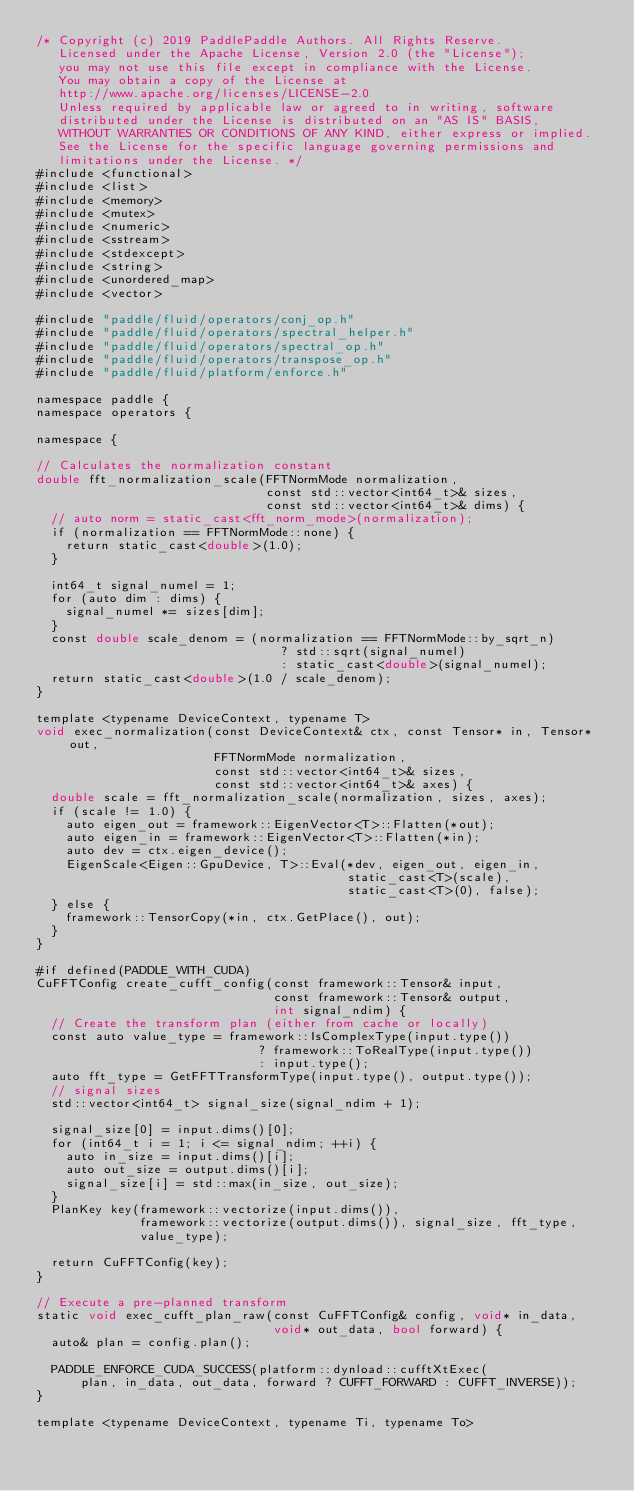<code> <loc_0><loc_0><loc_500><loc_500><_Cuda_>/* Copyright (c) 2019 PaddlePaddle Authors. All Rights Reserve.
   Licensed under the Apache License, Version 2.0 (the "License");
   you may not use this file except in compliance with the License.
   You may obtain a copy of the License at
   http://www.apache.org/licenses/LICENSE-2.0
   Unless required by applicable law or agreed to in writing, software
   distributed under the License is distributed on an "AS IS" BASIS,
   WITHOUT WARRANTIES OR CONDITIONS OF ANY KIND, either express or implied.
   See the License for the specific language governing permissions and
   limitations under the License. */
#include <functional>
#include <list>
#include <memory>
#include <mutex>
#include <numeric>
#include <sstream>
#include <stdexcept>
#include <string>
#include <unordered_map>
#include <vector>

#include "paddle/fluid/operators/conj_op.h"
#include "paddle/fluid/operators/spectral_helper.h"
#include "paddle/fluid/operators/spectral_op.h"
#include "paddle/fluid/operators/transpose_op.h"
#include "paddle/fluid/platform/enforce.h"

namespace paddle {
namespace operators {

namespace {

// Calculates the normalization constant
double fft_normalization_scale(FFTNormMode normalization,
                               const std::vector<int64_t>& sizes,
                               const std::vector<int64_t>& dims) {
  // auto norm = static_cast<fft_norm_mode>(normalization);
  if (normalization == FFTNormMode::none) {
    return static_cast<double>(1.0);
  }

  int64_t signal_numel = 1;
  for (auto dim : dims) {
    signal_numel *= sizes[dim];
  }
  const double scale_denom = (normalization == FFTNormMode::by_sqrt_n)
                                 ? std::sqrt(signal_numel)
                                 : static_cast<double>(signal_numel);
  return static_cast<double>(1.0 / scale_denom);
}

template <typename DeviceContext, typename T>
void exec_normalization(const DeviceContext& ctx, const Tensor* in, Tensor* out,
                        FFTNormMode normalization,
                        const std::vector<int64_t>& sizes,
                        const std::vector<int64_t>& axes) {
  double scale = fft_normalization_scale(normalization, sizes, axes);
  if (scale != 1.0) {
    auto eigen_out = framework::EigenVector<T>::Flatten(*out);
    auto eigen_in = framework::EigenVector<T>::Flatten(*in);
    auto dev = ctx.eigen_device();
    EigenScale<Eigen::GpuDevice, T>::Eval(*dev, eigen_out, eigen_in,
                                          static_cast<T>(scale),
                                          static_cast<T>(0), false);
  } else {
    framework::TensorCopy(*in, ctx.GetPlace(), out);
  }
}

#if defined(PADDLE_WITH_CUDA)
CuFFTConfig create_cufft_config(const framework::Tensor& input,
                                const framework::Tensor& output,
                                int signal_ndim) {
  // Create the transform plan (either from cache or locally)
  const auto value_type = framework::IsComplexType(input.type())
                              ? framework::ToRealType(input.type())
                              : input.type();
  auto fft_type = GetFFTTransformType(input.type(), output.type());
  // signal sizes
  std::vector<int64_t> signal_size(signal_ndim + 1);

  signal_size[0] = input.dims()[0];
  for (int64_t i = 1; i <= signal_ndim; ++i) {
    auto in_size = input.dims()[i];
    auto out_size = output.dims()[i];
    signal_size[i] = std::max(in_size, out_size);
  }
  PlanKey key(framework::vectorize(input.dims()),
              framework::vectorize(output.dims()), signal_size, fft_type,
              value_type);

  return CuFFTConfig(key);
}

// Execute a pre-planned transform
static void exec_cufft_plan_raw(const CuFFTConfig& config, void* in_data,
                                void* out_data, bool forward) {
  auto& plan = config.plan();

  PADDLE_ENFORCE_CUDA_SUCCESS(platform::dynload::cufftXtExec(
      plan, in_data, out_data, forward ? CUFFT_FORWARD : CUFFT_INVERSE));
}

template <typename DeviceContext, typename Ti, typename To></code> 